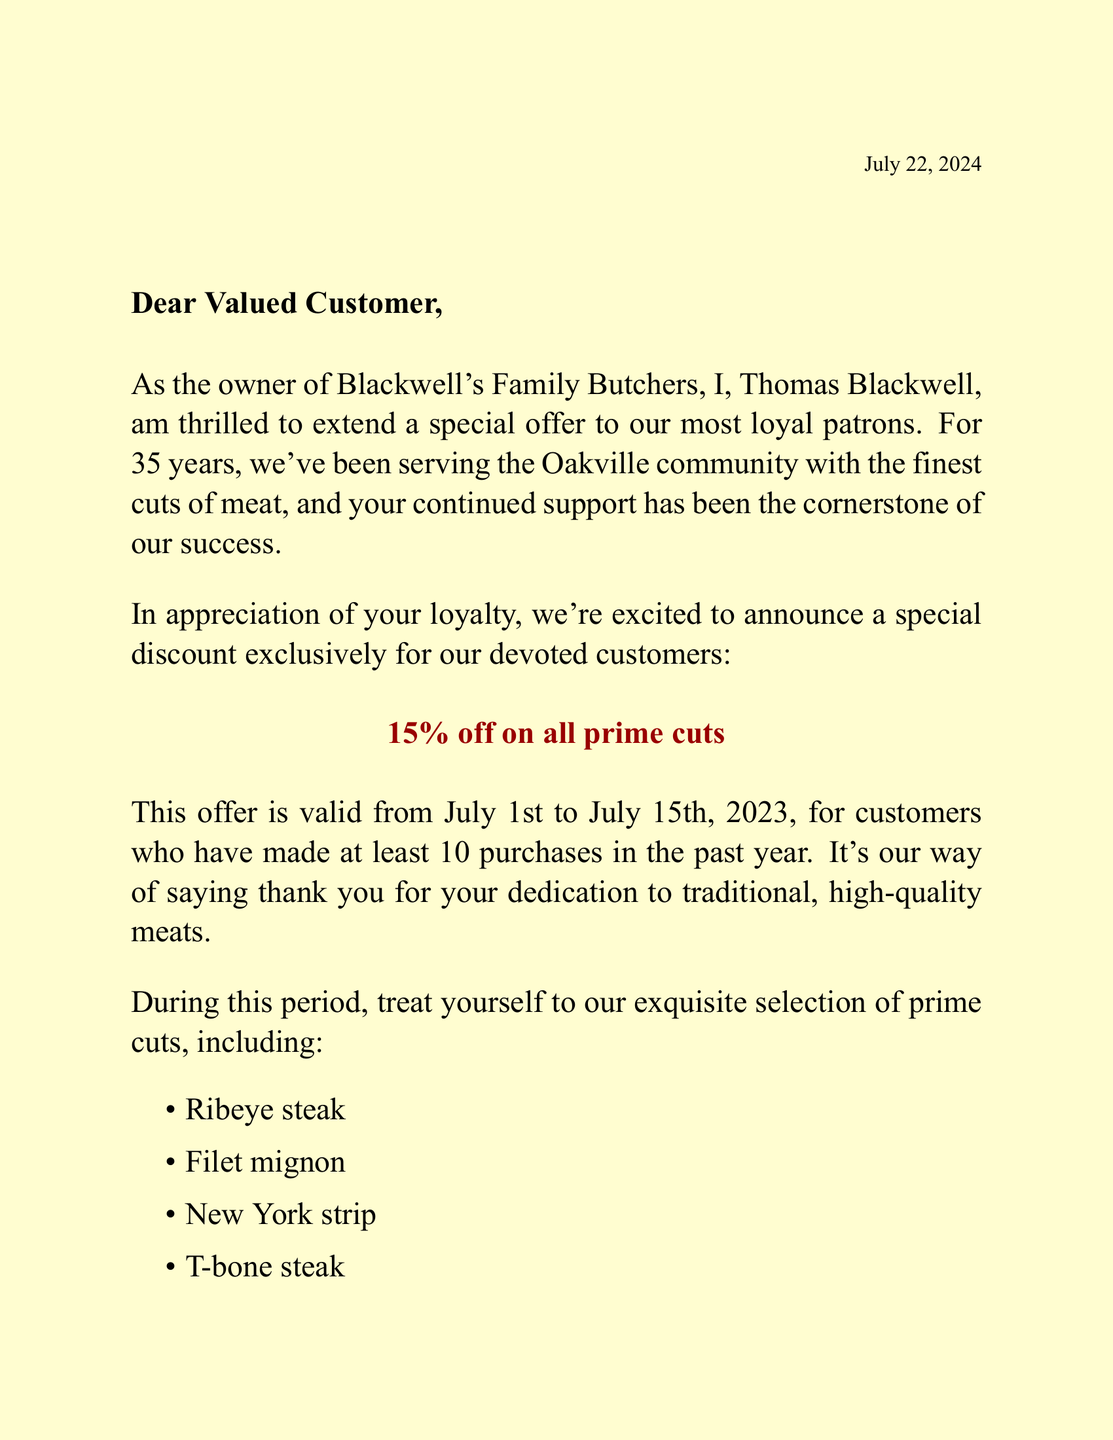What is the name of the butcher? The butcher's name is mentioned at the beginning of the letter as Thomas Blackwell.
Answer: Thomas Blackwell What is the location of the butcher shop? The letter specifies the address of the butcher shop, which is important for customers to find it.
Answer: 123 Main Street, Oakville What is the discount percentage offered on prime cuts? The letter explicitly states the discount percentage available to loyal customers.
Answer: 15% off What is the date range for the special discount? The letter provides specific dates during which the discount can be availed by customers.
Answer: July 1st to July 15th, 2023 How many purchases must a customer make to qualify for the discount? The document mentions the criteria for loyal customers to be eligible for the special discount.
Answer: 10 purchases What is a featured prime cut recommended in the letter? The letter lists several prime cuts, and asking for one can assess knowledge of the document’s content.
Answer: Ribeye steak What is the butcher's personal recommendation for a traditional meal? The letter includes a suggestion from the butcher for a specific cut suitable for a classic meal, showcasing his expertise.
Answer: Dry-aged ribeye What cooking tip does the butcher provide for steaks? The letter has specific advice about preparing steaks, which reflects an understanding of cooking techniques.
Answer: Bring steaks to room temperature before cooking What is the new product being introduced? The document announces a new addition to the butcher shop's offerings, which may attract customer interest.
Answer: House-made artisanal sausages 